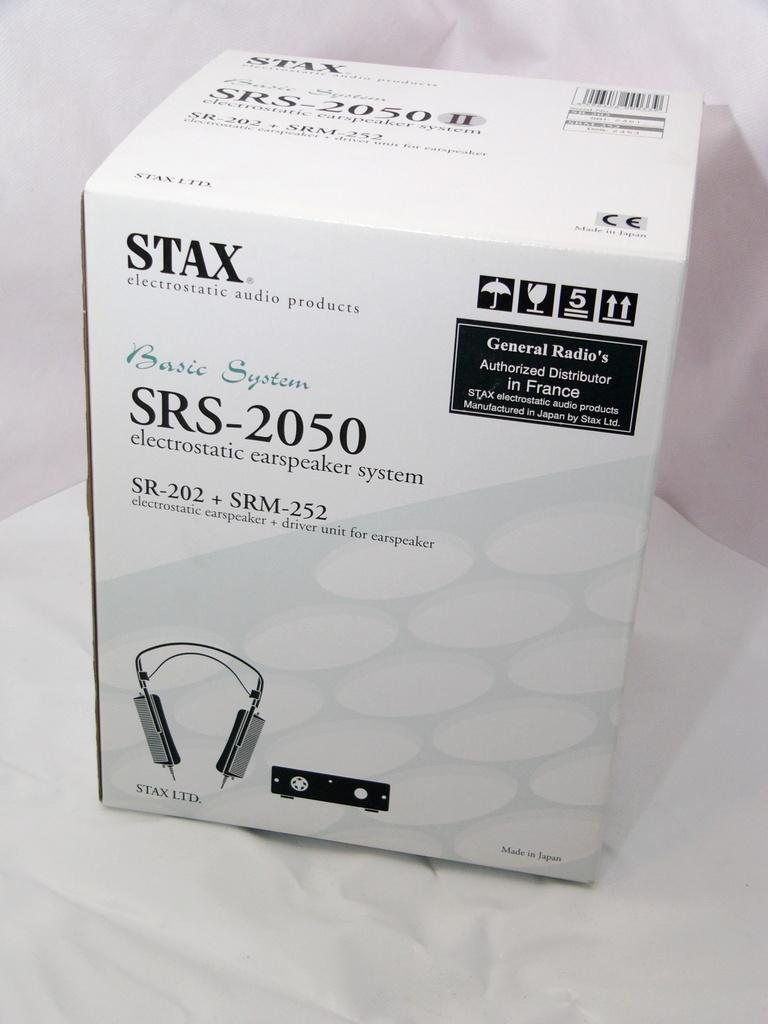<image>
Create a compact narrative representing the image presented. a small white box that says 'stax' on the top left corner of it 